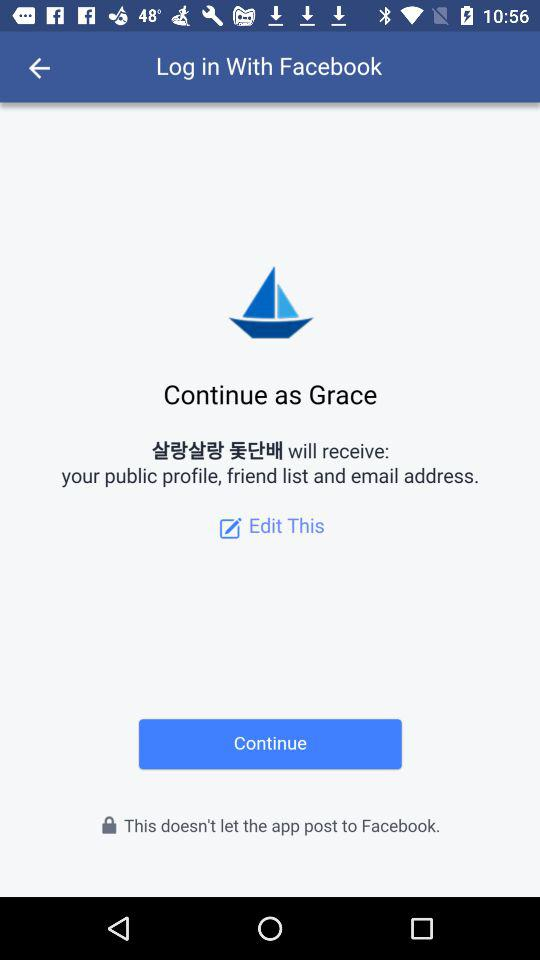Which application is asking for permission?
When the provided information is insufficient, respond with <no answer>. <no answer> 